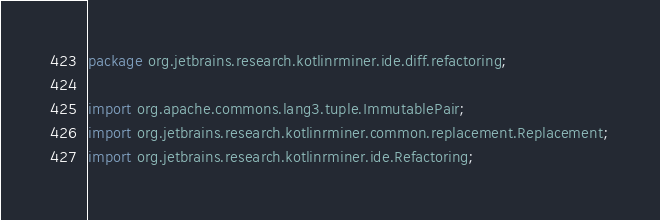Convert code to text. <code><loc_0><loc_0><loc_500><loc_500><_Java_>package org.jetbrains.research.kotlinrminer.ide.diff.refactoring;

import org.apache.commons.lang3.tuple.ImmutablePair;
import org.jetbrains.research.kotlinrminer.common.replacement.Replacement;
import org.jetbrains.research.kotlinrminer.ide.Refactoring;</code> 